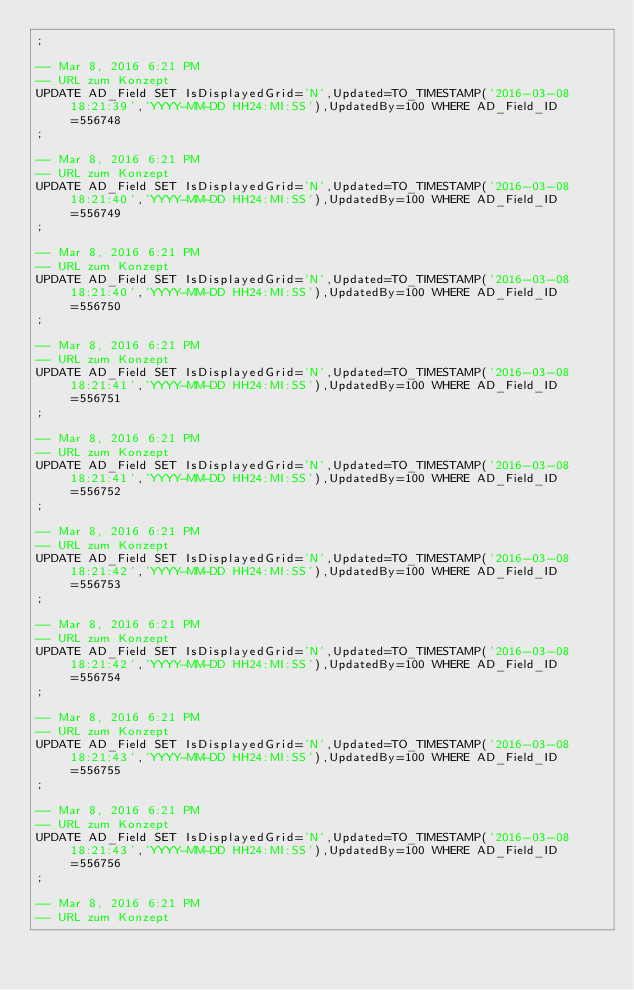<code> <loc_0><loc_0><loc_500><loc_500><_SQL_>;

-- Mar 8, 2016 6:21 PM
-- URL zum Konzept
UPDATE AD_Field SET IsDisplayedGrid='N',Updated=TO_TIMESTAMP('2016-03-08 18:21:39','YYYY-MM-DD HH24:MI:SS'),UpdatedBy=100 WHERE AD_Field_ID=556748
;

-- Mar 8, 2016 6:21 PM
-- URL zum Konzept
UPDATE AD_Field SET IsDisplayedGrid='N',Updated=TO_TIMESTAMP('2016-03-08 18:21:40','YYYY-MM-DD HH24:MI:SS'),UpdatedBy=100 WHERE AD_Field_ID=556749
;

-- Mar 8, 2016 6:21 PM
-- URL zum Konzept
UPDATE AD_Field SET IsDisplayedGrid='N',Updated=TO_TIMESTAMP('2016-03-08 18:21:40','YYYY-MM-DD HH24:MI:SS'),UpdatedBy=100 WHERE AD_Field_ID=556750
;

-- Mar 8, 2016 6:21 PM
-- URL zum Konzept
UPDATE AD_Field SET IsDisplayedGrid='N',Updated=TO_TIMESTAMP('2016-03-08 18:21:41','YYYY-MM-DD HH24:MI:SS'),UpdatedBy=100 WHERE AD_Field_ID=556751
;

-- Mar 8, 2016 6:21 PM
-- URL zum Konzept
UPDATE AD_Field SET IsDisplayedGrid='N',Updated=TO_TIMESTAMP('2016-03-08 18:21:41','YYYY-MM-DD HH24:MI:SS'),UpdatedBy=100 WHERE AD_Field_ID=556752
;

-- Mar 8, 2016 6:21 PM
-- URL zum Konzept
UPDATE AD_Field SET IsDisplayedGrid='N',Updated=TO_TIMESTAMP('2016-03-08 18:21:42','YYYY-MM-DD HH24:MI:SS'),UpdatedBy=100 WHERE AD_Field_ID=556753
;

-- Mar 8, 2016 6:21 PM
-- URL zum Konzept
UPDATE AD_Field SET IsDisplayedGrid='N',Updated=TO_TIMESTAMP('2016-03-08 18:21:42','YYYY-MM-DD HH24:MI:SS'),UpdatedBy=100 WHERE AD_Field_ID=556754
;

-- Mar 8, 2016 6:21 PM
-- URL zum Konzept
UPDATE AD_Field SET IsDisplayedGrid='N',Updated=TO_TIMESTAMP('2016-03-08 18:21:43','YYYY-MM-DD HH24:MI:SS'),UpdatedBy=100 WHERE AD_Field_ID=556755
;

-- Mar 8, 2016 6:21 PM
-- URL zum Konzept
UPDATE AD_Field SET IsDisplayedGrid='N',Updated=TO_TIMESTAMP('2016-03-08 18:21:43','YYYY-MM-DD HH24:MI:SS'),UpdatedBy=100 WHERE AD_Field_ID=556756
;

-- Mar 8, 2016 6:21 PM
-- URL zum Konzept</code> 